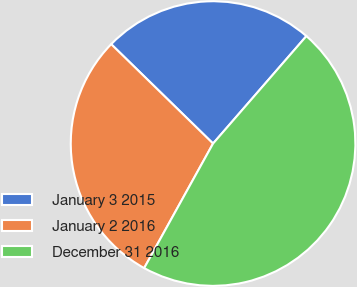Convert chart. <chart><loc_0><loc_0><loc_500><loc_500><pie_chart><fcel>January 3 2015<fcel>January 2 2016<fcel>December 31 2016<nl><fcel>24.08%<fcel>29.26%<fcel>46.66%<nl></chart> 